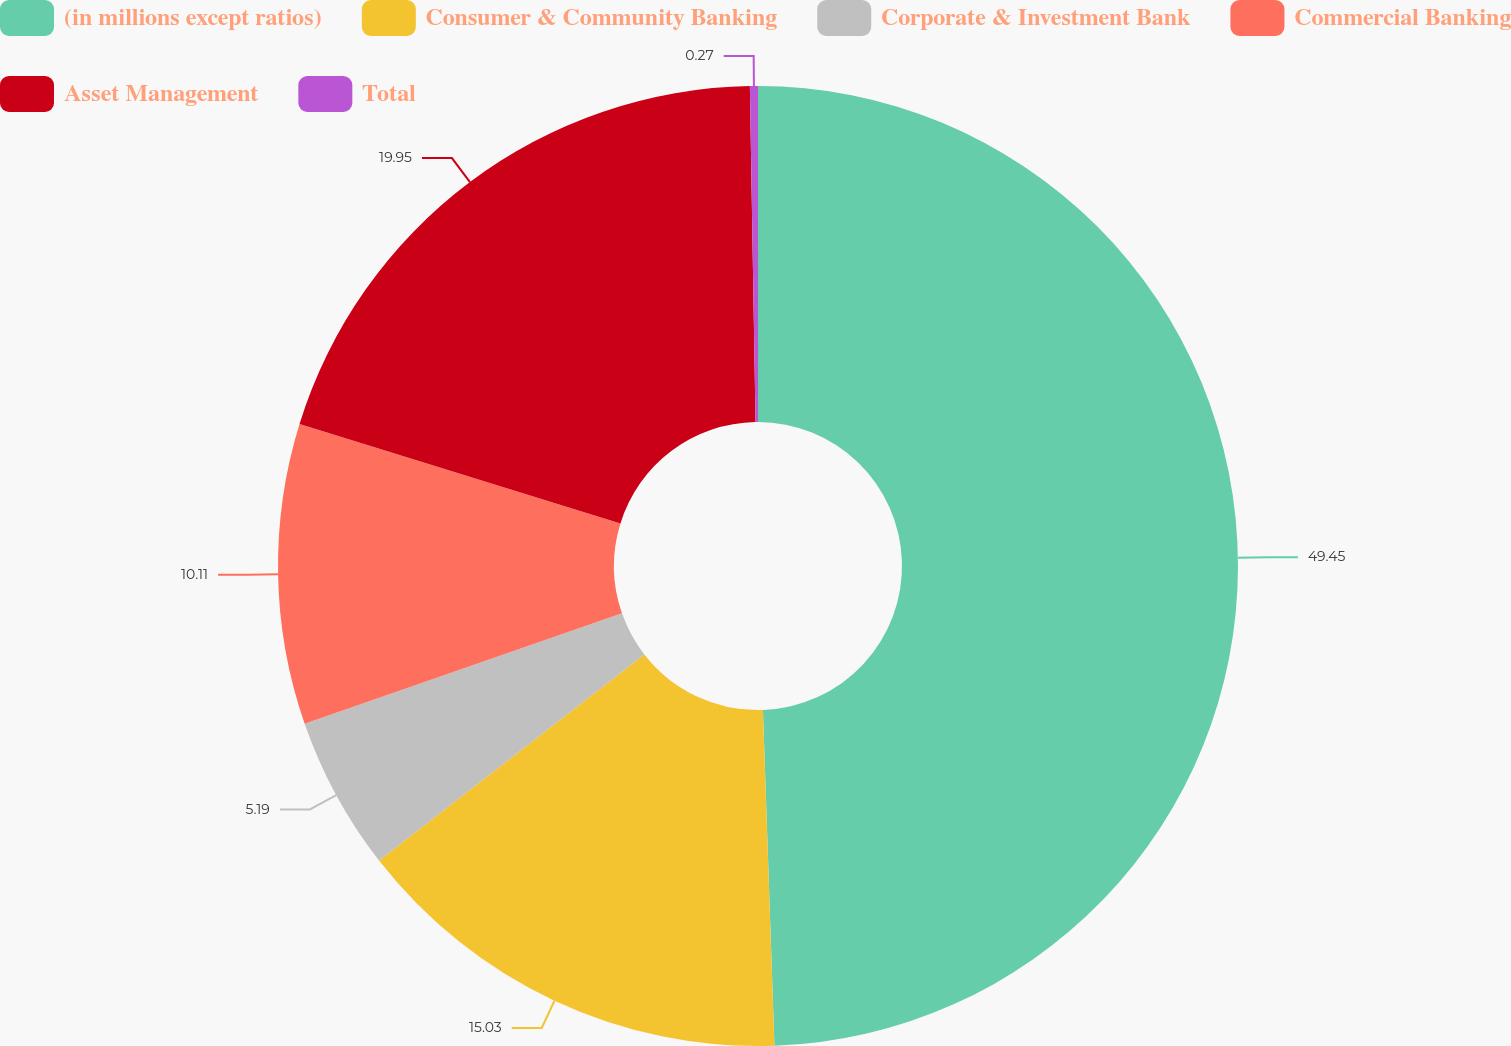Convert chart to OTSL. <chart><loc_0><loc_0><loc_500><loc_500><pie_chart><fcel>(in millions except ratios)<fcel>Consumer & Community Banking<fcel>Corporate & Investment Bank<fcel>Commercial Banking<fcel>Asset Management<fcel>Total<nl><fcel>49.46%<fcel>15.03%<fcel>5.19%<fcel>10.11%<fcel>19.95%<fcel>0.27%<nl></chart> 